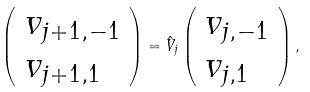<formula> <loc_0><loc_0><loc_500><loc_500>\left ( \begin{array} { l } { v } _ { j + 1 , - 1 } \\ { v } _ { j + 1 , 1 } \end{array} \right ) = \hat { V } _ { j } \left ( \begin{array} { l } { v } _ { j , - 1 } \\ { v } _ { j , 1 } \end{array} \right ) ,</formula> 